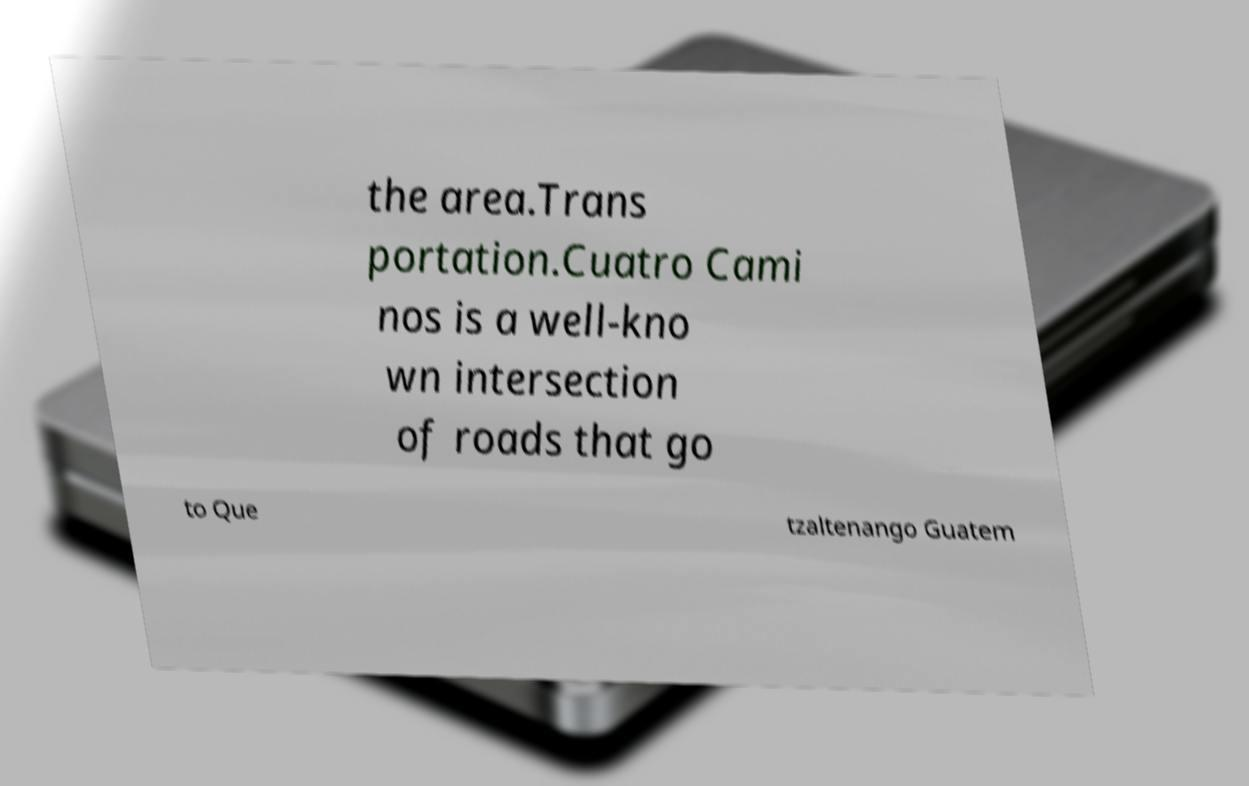For documentation purposes, I need the text within this image transcribed. Could you provide that? the area.Trans portation.Cuatro Cami nos is a well-kno wn intersection of roads that go to Que tzaltenango Guatem 